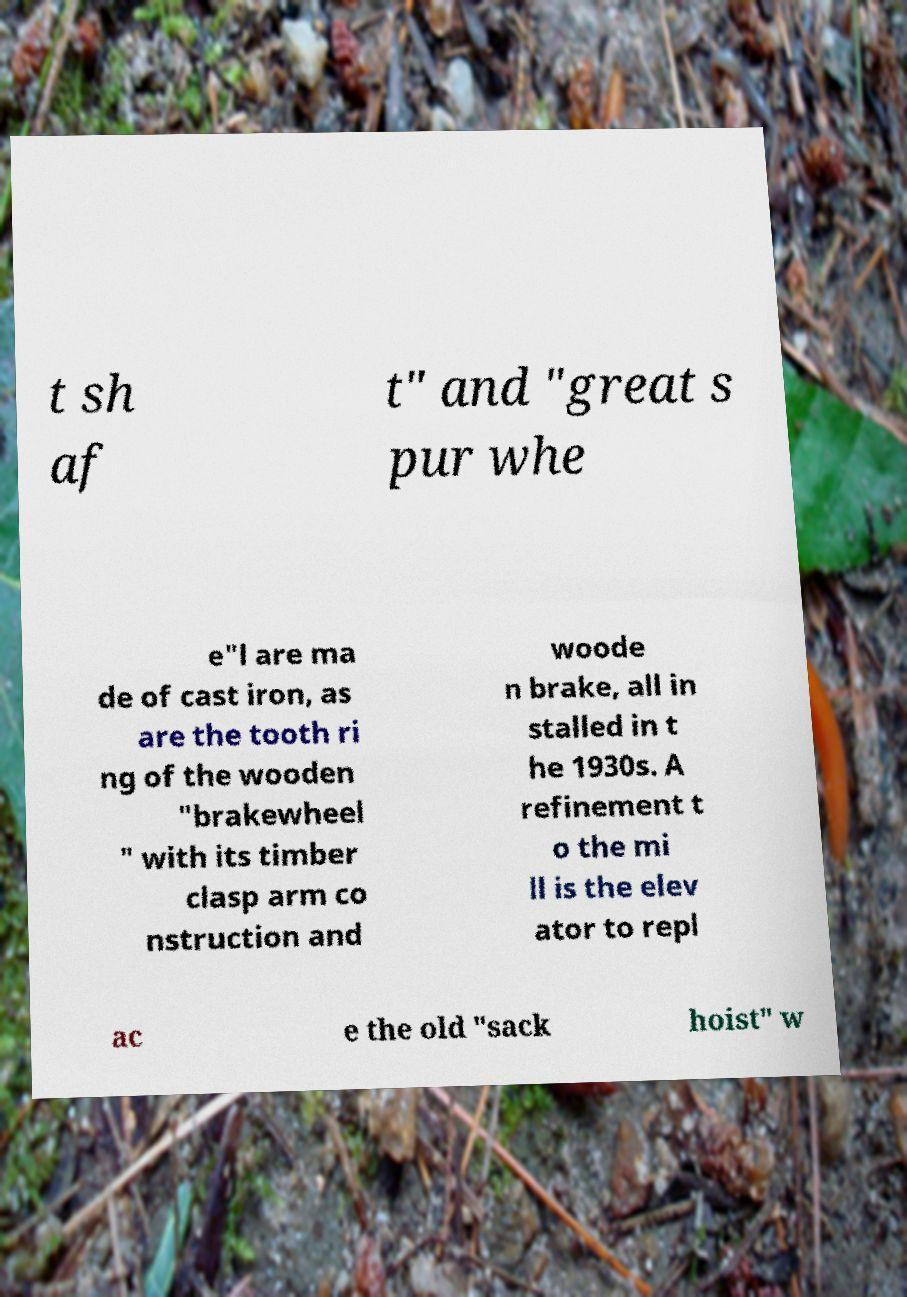Please identify and transcribe the text found in this image. t sh af t" and "great s pur whe e"l are ma de of cast iron, as are the tooth ri ng of the wooden "brakewheel " with its timber clasp arm co nstruction and woode n brake, all in stalled in t he 1930s. A refinement t o the mi ll is the elev ator to repl ac e the old "sack hoist" w 